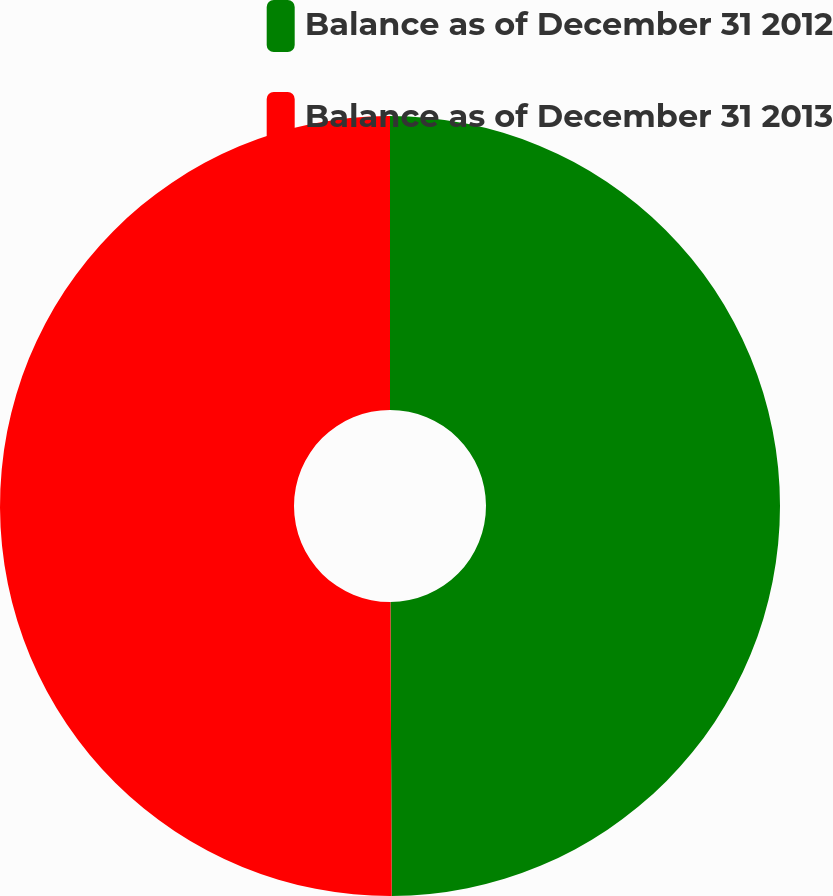Convert chart. <chart><loc_0><loc_0><loc_500><loc_500><pie_chart><fcel>Balance as of December 31 2012<fcel>Balance as of December 31 2013<nl><fcel>49.93%<fcel>50.07%<nl></chart> 